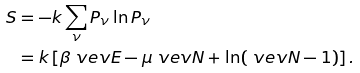<formula> <loc_0><loc_0><loc_500><loc_500>S & = - k \sum _ { \nu } P _ { \nu } \ln P _ { \nu } \\ & = k \left [ \beta \ v e v { E } - \mu \ v e v { N } + \ln ( \ v e v { N } - 1 ) \right ] .</formula> 